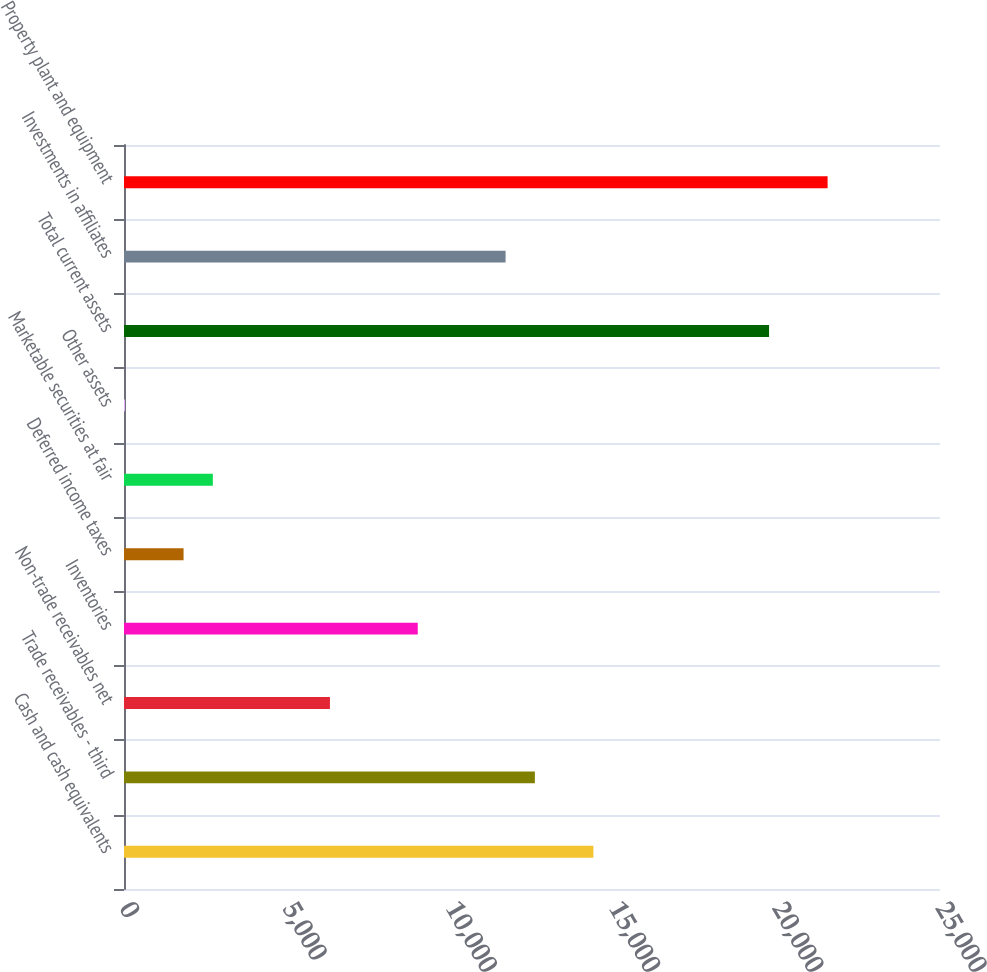Convert chart. <chart><loc_0><loc_0><loc_500><loc_500><bar_chart><fcel>Cash and cash equivalents<fcel>Trade receivables - third<fcel>Non-trade receivables net<fcel>Inventories<fcel>Deferred income taxes<fcel>Marketable securities at fair<fcel>Other assets<fcel>Total current assets<fcel>Investments in affiliates<fcel>Property plant and equipment<nl><fcel>14381.4<fcel>12587.6<fcel>6309.3<fcel>9000<fcel>1824.8<fcel>2721.7<fcel>31<fcel>19762.8<fcel>11690.7<fcel>21556.6<nl></chart> 